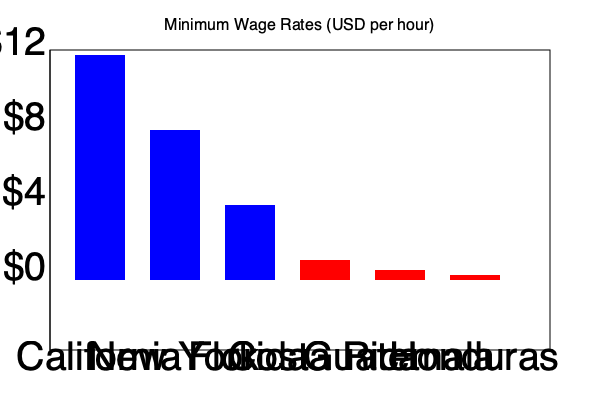Based on the bar chart comparing minimum wage rates across different US states and Central American countries, what observation can be made about the difference in minimum wages between the United States and Central America, and how might this impact immigration patterns? To answer this question, let's analyze the bar chart step-by-step:

1. US States minimum wages:
   - California: Approximately $12/hour
   - New York: Approximately $8/hour
   - Florida: Approximately $4/hour

2. Central American countries minimum wages:
   - Costa Rica: Approximately $1/hour
   - Guatemala: Approximately $0.50/hour
   - Honduras: Approximately $0.25/hour

3. Comparison:
   - The lowest US minimum wage shown (Florida at $4/hour) is still significantly higher than the highest Central American minimum wage (Costa Rica at $1/hour).
   - The highest US minimum wage (California at $12/hour) is about 48 times higher than the lowest Central American minimum wage (Honduras at $0.25/hour).

4. Impact on immigration patterns:
   - The substantial wage difference creates a strong economic incentive for workers from Central American countries to seek employment opportunities in the United States.
   - Even lower-paying jobs in the US can potentially offer significantly higher wages than what workers might earn in their home countries.
   - This wage disparity can be a major factor driving immigration from Central America to the United States, as people seek better economic opportunities and living standards for themselves and their families.

5. Additional considerations:
   - While the wage difference is substantial, it's important to note that living costs in the US are generally higher than in Central American countries.
   - Other factors, such as job availability, social networks, and immigration policies, also play crucial roles in shaping immigration patterns.
Answer: The minimum wages in US states are significantly higher than in Central American countries, potentially driving immigration to the US for better economic opportunities. 